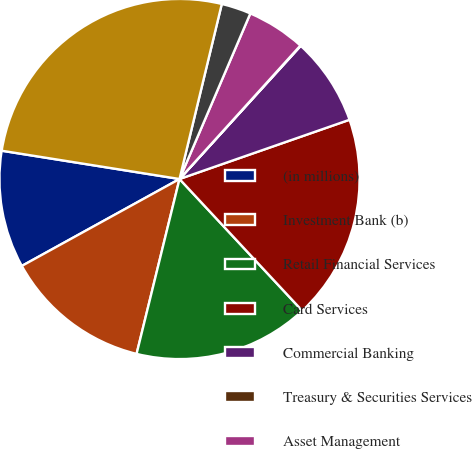Convert chart. <chart><loc_0><loc_0><loc_500><loc_500><pie_chart><fcel>(in millions)<fcel>Investment Bank (b)<fcel>Retail Financial Services<fcel>Card Services<fcel>Commercial Banking<fcel>Treasury & Securities Services<fcel>Asset Management<fcel>Corporate/Private Equity (b)<fcel>Total<nl><fcel>10.53%<fcel>13.15%<fcel>15.77%<fcel>18.4%<fcel>7.91%<fcel>0.04%<fcel>5.28%<fcel>2.66%<fcel>26.26%<nl></chart> 